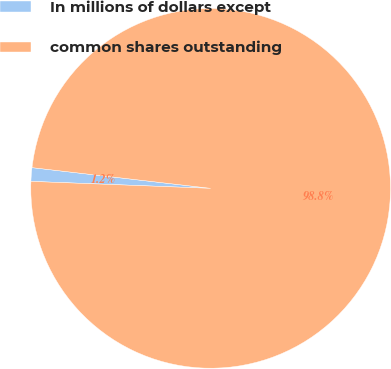Convert chart. <chart><loc_0><loc_0><loc_500><loc_500><pie_chart><fcel>In millions of dollars except<fcel>common shares outstanding<nl><fcel>1.22%<fcel>98.78%<nl></chart> 